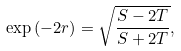<formula> <loc_0><loc_0><loc_500><loc_500>\exp \left ( - 2 r \right ) = \sqrt { \frac { S - 2 T } { S + 2 T } } ,</formula> 